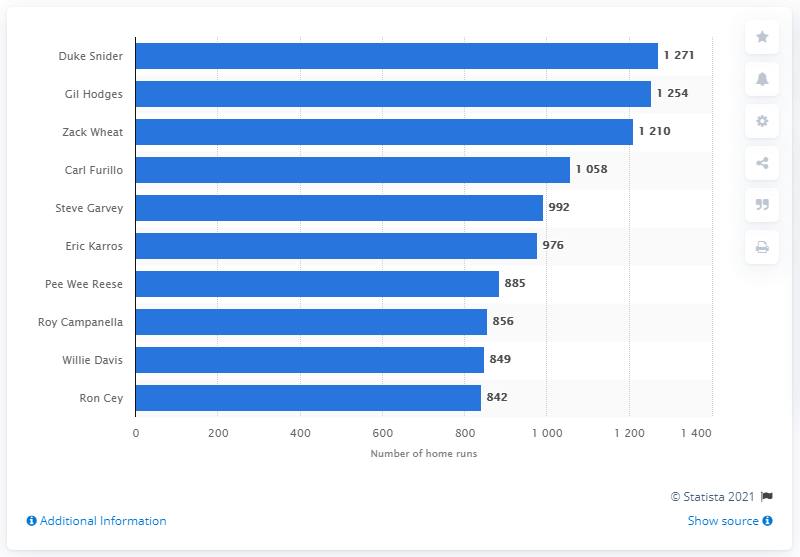Outline some significant characteristics in this image. Duke Snider holds the record for the most RBI in the history of the Los Angeles Dodgers franchise. 